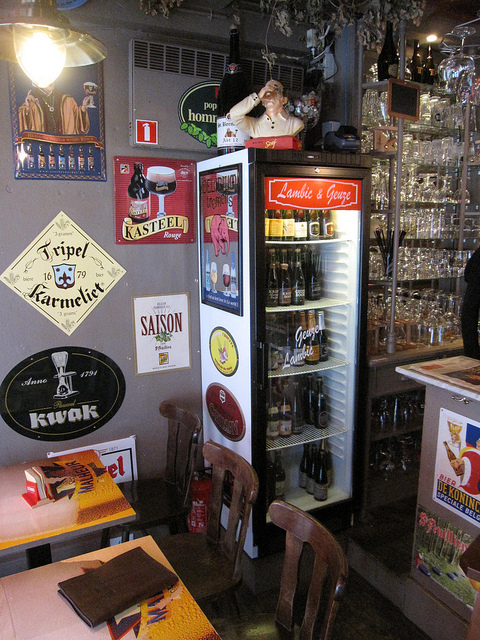Describe the atmosphere or style of this place. The atmosphere seems to evoke a rustic and inviting ambience, with a touch of nostalgia. Various beer-related décor, including vintage signs and a variety of glasses, contribute to the character of what appears to be a down-to-earth, Belgian-inspired pub or café. 